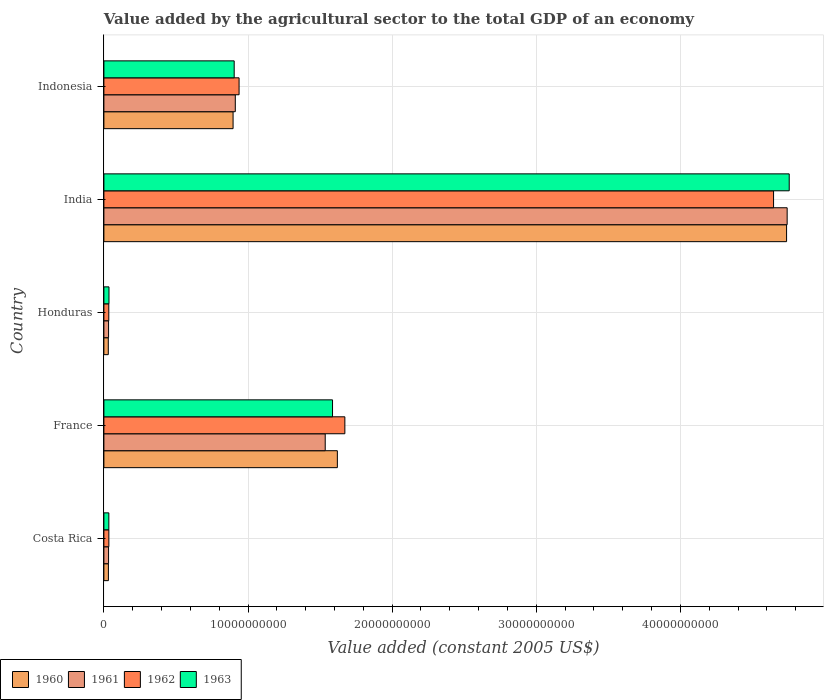How many different coloured bars are there?
Give a very brief answer. 4. Are the number of bars per tick equal to the number of legend labels?
Make the answer very short. Yes. How many bars are there on the 2nd tick from the top?
Ensure brevity in your answer.  4. How many bars are there on the 5th tick from the bottom?
Keep it short and to the point. 4. What is the value added by the agricultural sector in 1961 in Indonesia?
Provide a succinct answer. 9.12e+09. Across all countries, what is the maximum value added by the agricultural sector in 1962?
Provide a succinct answer. 4.65e+1. Across all countries, what is the minimum value added by the agricultural sector in 1962?
Provide a succinct answer. 3.41e+08. In which country was the value added by the agricultural sector in 1960 minimum?
Offer a terse response. Honduras. What is the total value added by the agricultural sector in 1961 in the graph?
Your answer should be very brief. 7.25e+1. What is the difference between the value added by the agricultural sector in 1960 in Honduras and that in Indonesia?
Provide a succinct answer. -8.66e+09. What is the difference between the value added by the agricultural sector in 1961 in India and the value added by the agricultural sector in 1960 in France?
Give a very brief answer. 3.12e+1. What is the average value added by the agricultural sector in 1961 per country?
Your answer should be compact. 1.45e+1. What is the difference between the value added by the agricultural sector in 1963 and value added by the agricultural sector in 1962 in Honduras?
Provide a short and direct response. 1.24e+07. In how many countries, is the value added by the agricultural sector in 1961 greater than 24000000000 US$?
Offer a very short reply. 1. What is the ratio of the value added by the agricultural sector in 1961 in France to that in Indonesia?
Keep it short and to the point. 1.68. Is the value added by the agricultural sector in 1963 in Costa Rica less than that in India?
Give a very brief answer. Yes. What is the difference between the highest and the second highest value added by the agricultural sector in 1963?
Give a very brief answer. 3.17e+1. What is the difference between the highest and the lowest value added by the agricultural sector in 1962?
Offer a terse response. 4.61e+1. In how many countries, is the value added by the agricultural sector in 1962 greater than the average value added by the agricultural sector in 1962 taken over all countries?
Offer a very short reply. 2. Is the sum of the value added by the agricultural sector in 1960 in Costa Rica and Indonesia greater than the maximum value added by the agricultural sector in 1961 across all countries?
Make the answer very short. No. Is it the case that in every country, the sum of the value added by the agricultural sector in 1961 and value added by the agricultural sector in 1962 is greater than the sum of value added by the agricultural sector in 1960 and value added by the agricultural sector in 1963?
Keep it short and to the point. No. What does the 1st bar from the top in India represents?
Provide a short and direct response. 1963. What does the 3rd bar from the bottom in Indonesia represents?
Your answer should be very brief. 1962. How many bars are there?
Ensure brevity in your answer.  20. Are all the bars in the graph horizontal?
Offer a very short reply. Yes. How many countries are there in the graph?
Your response must be concise. 5. What is the difference between two consecutive major ticks on the X-axis?
Offer a terse response. 1.00e+1. Does the graph contain any zero values?
Ensure brevity in your answer.  No. Does the graph contain grids?
Provide a short and direct response. Yes. How many legend labels are there?
Make the answer very short. 4. What is the title of the graph?
Keep it short and to the point. Value added by the agricultural sector to the total GDP of an economy. Does "1995" appear as one of the legend labels in the graph?
Make the answer very short. No. What is the label or title of the X-axis?
Offer a terse response. Value added (constant 2005 US$). What is the label or title of the Y-axis?
Offer a terse response. Country. What is the Value added (constant 2005 US$) of 1960 in Costa Rica?
Your answer should be very brief. 3.13e+08. What is the Value added (constant 2005 US$) in 1961 in Costa Rica?
Ensure brevity in your answer.  3.24e+08. What is the Value added (constant 2005 US$) in 1962 in Costa Rica?
Provide a short and direct response. 3.44e+08. What is the Value added (constant 2005 US$) in 1963 in Costa Rica?
Offer a terse response. 3.43e+08. What is the Value added (constant 2005 US$) in 1960 in France?
Your response must be concise. 1.62e+1. What is the Value added (constant 2005 US$) of 1961 in France?
Offer a very short reply. 1.54e+1. What is the Value added (constant 2005 US$) of 1962 in France?
Offer a very short reply. 1.67e+1. What is the Value added (constant 2005 US$) of 1963 in France?
Your response must be concise. 1.59e+1. What is the Value added (constant 2005 US$) in 1960 in Honduras?
Keep it short and to the point. 3.05e+08. What is the Value added (constant 2005 US$) in 1961 in Honduras?
Offer a very short reply. 3.25e+08. What is the Value added (constant 2005 US$) in 1962 in Honduras?
Your answer should be compact. 3.41e+08. What is the Value added (constant 2005 US$) of 1963 in Honduras?
Provide a short and direct response. 3.53e+08. What is the Value added (constant 2005 US$) of 1960 in India?
Make the answer very short. 4.74e+1. What is the Value added (constant 2005 US$) of 1961 in India?
Provide a short and direct response. 4.74e+1. What is the Value added (constant 2005 US$) of 1962 in India?
Provide a short and direct response. 4.65e+1. What is the Value added (constant 2005 US$) of 1963 in India?
Provide a succinct answer. 4.76e+1. What is the Value added (constant 2005 US$) of 1960 in Indonesia?
Your answer should be compact. 8.96e+09. What is the Value added (constant 2005 US$) of 1961 in Indonesia?
Provide a succinct answer. 9.12e+09. What is the Value added (constant 2005 US$) in 1962 in Indonesia?
Ensure brevity in your answer.  9.38e+09. What is the Value added (constant 2005 US$) in 1963 in Indonesia?
Your answer should be very brief. 9.04e+09. Across all countries, what is the maximum Value added (constant 2005 US$) in 1960?
Give a very brief answer. 4.74e+1. Across all countries, what is the maximum Value added (constant 2005 US$) of 1961?
Offer a terse response. 4.74e+1. Across all countries, what is the maximum Value added (constant 2005 US$) in 1962?
Offer a very short reply. 4.65e+1. Across all countries, what is the maximum Value added (constant 2005 US$) of 1963?
Give a very brief answer. 4.76e+1. Across all countries, what is the minimum Value added (constant 2005 US$) of 1960?
Give a very brief answer. 3.05e+08. Across all countries, what is the minimum Value added (constant 2005 US$) in 1961?
Provide a short and direct response. 3.24e+08. Across all countries, what is the minimum Value added (constant 2005 US$) of 1962?
Your answer should be very brief. 3.41e+08. Across all countries, what is the minimum Value added (constant 2005 US$) of 1963?
Provide a short and direct response. 3.43e+08. What is the total Value added (constant 2005 US$) of 1960 in the graph?
Provide a succinct answer. 7.31e+1. What is the total Value added (constant 2005 US$) of 1961 in the graph?
Give a very brief answer. 7.25e+1. What is the total Value added (constant 2005 US$) in 1962 in the graph?
Provide a succinct answer. 7.32e+1. What is the total Value added (constant 2005 US$) of 1963 in the graph?
Provide a short and direct response. 7.32e+1. What is the difference between the Value added (constant 2005 US$) of 1960 in Costa Rica and that in France?
Your response must be concise. -1.59e+1. What is the difference between the Value added (constant 2005 US$) in 1961 in Costa Rica and that in France?
Provide a succinct answer. -1.50e+1. What is the difference between the Value added (constant 2005 US$) of 1962 in Costa Rica and that in France?
Your response must be concise. -1.64e+1. What is the difference between the Value added (constant 2005 US$) in 1963 in Costa Rica and that in France?
Provide a short and direct response. -1.55e+1. What is the difference between the Value added (constant 2005 US$) in 1960 in Costa Rica and that in Honduras?
Provide a short and direct response. 7.61e+06. What is the difference between the Value added (constant 2005 US$) of 1961 in Costa Rica and that in Honduras?
Ensure brevity in your answer.  -8.14e+05. What is the difference between the Value added (constant 2005 US$) of 1962 in Costa Rica and that in Honduras?
Make the answer very short. 3.61e+06. What is the difference between the Value added (constant 2005 US$) of 1963 in Costa Rica and that in Honduras?
Your answer should be compact. -9.78e+06. What is the difference between the Value added (constant 2005 US$) of 1960 in Costa Rica and that in India?
Provide a short and direct response. -4.71e+1. What is the difference between the Value added (constant 2005 US$) of 1961 in Costa Rica and that in India?
Ensure brevity in your answer.  -4.71e+1. What is the difference between the Value added (constant 2005 US$) of 1962 in Costa Rica and that in India?
Ensure brevity in your answer.  -4.61e+1. What is the difference between the Value added (constant 2005 US$) of 1963 in Costa Rica and that in India?
Your response must be concise. -4.72e+1. What is the difference between the Value added (constant 2005 US$) in 1960 in Costa Rica and that in Indonesia?
Ensure brevity in your answer.  -8.65e+09. What is the difference between the Value added (constant 2005 US$) in 1961 in Costa Rica and that in Indonesia?
Provide a short and direct response. -8.79e+09. What is the difference between the Value added (constant 2005 US$) of 1962 in Costa Rica and that in Indonesia?
Keep it short and to the point. -9.03e+09. What is the difference between the Value added (constant 2005 US$) in 1963 in Costa Rica and that in Indonesia?
Keep it short and to the point. -8.70e+09. What is the difference between the Value added (constant 2005 US$) of 1960 in France and that in Honduras?
Offer a very short reply. 1.59e+1. What is the difference between the Value added (constant 2005 US$) of 1961 in France and that in Honduras?
Keep it short and to the point. 1.50e+1. What is the difference between the Value added (constant 2005 US$) of 1962 in France and that in Honduras?
Provide a succinct answer. 1.64e+1. What is the difference between the Value added (constant 2005 US$) in 1963 in France and that in Honduras?
Make the answer very short. 1.55e+1. What is the difference between the Value added (constant 2005 US$) of 1960 in France and that in India?
Your response must be concise. -3.12e+1. What is the difference between the Value added (constant 2005 US$) of 1961 in France and that in India?
Make the answer very short. -3.21e+1. What is the difference between the Value added (constant 2005 US$) in 1962 in France and that in India?
Offer a terse response. -2.97e+1. What is the difference between the Value added (constant 2005 US$) in 1963 in France and that in India?
Provide a succinct answer. -3.17e+1. What is the difference between the Value added (constant 2005 US$) of 1960 in France and that in Indonesia?
Make the answer very short. 7.24e+09. What is the difference between the Value added (constant 2005 US$) of 1961 in France and that in Indonesia?
Your answer should be compact. 6.24e+09. What is the difference between the Value added (constant 2005 US$) of 1962 in France and that in Indonesia?
Offer a very short reply. 7.34e+09. What is the difference between the Value added (constant 2005 US$) of 1963 in France and that in Indonesia?
Provide a succinct answer. 6.82e+09. What is the difference between the Value added (constant 2005 US$) of 1960 in Honduras and that in India?
Your answer should be compact. -4.71e+1. What is the difference between the Value added (constant 2005 US$) in 1961 in Honduras and that in India?
Your answer should be compact. -4.71e+1. What is the difference between the Value added (constant 2005 US$) of 1962 in Honduras and that in India?
Keep it short and to the point. -4.61e+1. What is the difference between the Value added (constant 2005 US$) of 1963 in Honduras and that in India?
Provide a short and direct response. -4.72e+1. What is the difference between the Value added (constant 2005 US$) in 1960 in Honduras and that in Indonesia?
Offer a very short reply. -8.66e+09. What is the difference between the Value added (constant 2005 US$) in 1961 in Honduras and that in Indonesia?
Your answer should be very brief. -8.79e+09. What is the difference between the Value added (constant 2005 US$) in 1962 in Honduras and that in Indonesia?
Offer a very short reply. -9.04e+09. What is the difference between the Value added (constant 2005 US$) of 1963 in Honduras and that in Indonesia?
Provide a short and direct response. -8.69e+09. What is the difference between the Value added (constant 2005 US$) in 1960 in India and that in Indonesia?
Make the answer very short. 3.84e+1. What is the difference between the Value added (constant 2005 US$) in 1961 in India and that in Indonesia?
Keep it short and to the point. 3.83e+1. What is the difference between the Value added (constant 2005 US$) in 1962 in India and that in Indonesia?
Give a very brief answer. 3.71e+1. What is the difference between the Value added (constant 2005 US$) of 1963 in India and that in Indonesia?
Keep it short and to the point. 3.85e+1. What is the difference between the Value added (constant 2005 US$) of 1960 in Costa Rica and the Value added (constant 2005 US$) of 1961 in France?
Your answer should be very brief. -1.50e+1. What is the difference between the Value added (constant 2005 US$) in 1960 in Costa Rica and the Value added (constant 2005 US$) in 1962 in France?
Offer a very short reply. -1.64e+1. What is the difference between the Value added (constant 2005 US$) in 1960 in Costa Rica and the Value added (constant 2005 US$) in 1963 in France?
Provide a succinct answer. -1.56e+1. What is the difference between the Value added (constant 2005 US$) of 1961 in Costa Rica and the Value added (constant 2005 US$) of 1962 in France?
Keep it short and to the point. -1.64e+1. What is the difference between the Value added (constant 2005 US$) of 1961 in Costa Rica and the Value added (constant 2005 US$) of 1963 in France?
Offer a very short reply. -1.55e+1. What is the difference between the Value added (constant 2005 US$) in 1962 in Costa Rica and the Value added (constant 2005 US$) in 1963 in France?
Your answer should be very brief. -1.55e+1. What is the difference between the Value added (constant 2005 US$) of 1960 in Costa Rica and the Value added (constant 2005 US$) of 1961 in Honduras?
Your answer should be very brief. -1.23e+07. What is the difference between the Value added (constant 2005 US$) in 1960 in Costa Rica and the Value added (constant 2005 US$) in 1962 in Honduras?
Ensure brevity in your answer.  -2.78e+07. What is the difference between the Value added (constant 2005 US$) in 1960 in Costa Rica and the Value added (constant 2005 US$) in 1963 in Honduras?
Provide a succinct answer. -4.02e+07. What is the difference between the Value added (constant 2005 US$) of 1961 in Costa Rica and the Value added (constant 2005 US$) of 1962 in Honduras?
Offer a terse response. -1.63e+07. What is the difference between the Value added (constant 2005 US$) of 1961 in Costa Rica and the Value added (constant 2005 US$) of 1963 in Honduras?
Offer a very short reply. -2.87e+07. What is the difference between the Value added (constant 2005 US$) of 1962 in Costa Rica and the Value added (constant 2005 US$) of 1963 in Honduras?
Provide a short and direct response. -8.78e+06. What is the difference between the Value added (constant 2005 US$) of 1960 in Costa Rica and the Value added (constant 2005 US$) of 1961 in India?
Provide a succinct answer. -4.71e+1. What is the difference between the Value added (constant 2005 US$) in 1960 in Costa Rica and the Value added (constant 2005 US$) in 1962 in India?
Your answer should be compact. -4.62e+1. What is the difference between the Value added (constant 2005 US$) in 1960 in Costa Rica and the Value added (constant 2005 US$) in 1963 in India?
Make the answer very short. -4.72e+1. What is the difference between the Value added (constant 2005 US$) of 1961 in Costa Rica and the Value added (constant 2005 US$) of 1962 in India?
Provide a succinct answer. -4.61e+1. What is the difference between the Value added (constant 2005 US$) of 1961 in Costa Rica and the Value added (constant 2005 US$) of 1963 in India?
Keep it short and to the point. -4.72e+1. What is the difference between the Value added (constant 2005 US$) of 1962 in Costa Rica and the Value added (constant 2005 US$) of 1963 in India?
Your answer should be very brief. -4.72e+1. What is the difference between the Value added (constant 2005 US$) of 1960 in Costa Rica and the Value added (constant 2005 US$) of 1961 in Indonesia?
Your answer should be compact. -8.80e+09. What is the difference between the Value added (constant 2005 US$) in 1960 in Costa Rica and the Value added (constant 2005 US$) in 1962 in Indonesia?
Ensure brevity in your answer.  -9.07e+09. What is the difference between the Value added (constant 2005 US$) of 1960 in Costa Rica and the Value added (constant 2005 US$) of 1963 in Indonesia?
Give a very brief answer. -8.73e+09. What is the difference between the Value added (constant 2005 US$) in 1961 in Costa Rica and the Value added (constant 2005 US$) in 1962 in Indonesia?
Keep it short and to the point. -9.05e+09. What is the difference between the Value added (constant 2005 US$) in 1961 in Costa Rica and the Value added (constant 2005 US$) in 1963 in Indonesia?
Your answer should be compact. -8.72e+09. What is the difference between the Value added (constant 2005 US$) in 1962 in Costa Rica and the Value added (constant 2005 US$) in 1963 in Indonesia?
Offer a very short reply. -8.70e+09. What is the difference between the Value added (constant 2005 US$) in 1960 in France and the Value added (constant 2005 US$) in 1961 in Honduras?
Offer a terse response. 1.59e+1. What is the difference between the Value added (constant 2005 US$) of 1960 in France and the Value added (constant 2005 US$) of 1962 in Honduras?
Keep it short and to the point. 1.59e+1. What is the difference between the Value added (constant 2005 US$) in 1960 in France and the Value added (constant 2005 US$) in 1963 in Honduras?
Ensure brevity in your answer.  1.58e+1. What is the difference between the Value added (constant 2005 US$) in 1961 in France and the Value added (constant 2005 US$) in 1962 in Honduras?
Ensure brevity in your answer.  1.50e+1. What is the difference between the Value added (constant 2005 US$) of 1961 in France and the Value added (constant 2005 US$) of 1963 in Honduras?
Your response must be concise. 1.50e+1. What is the difference between the Value added (constant 2005 US$) of 1962 in France and the Value added (constant 2005 US$) of 1963 in Honduras?
Your answer should be very brief. 1.64e+1. What is the difference between the Value added (constant 2005 US$) in 1960 in France and the Value added (constant 2005 US$) in 1961 in India?
Keep it short and to the point. -3.12e+1. What is the difference between the Value added (constant 2005 US$) in 1960 in France and the Value added (constant 2005 US$) in 1962 in India?
Provide a short and direct response. -3.03e+1. What is the difference between the Value added (constant 2005 US$) of 1960 in France and the Value added (constant 2005 US$) of 1963 in India?
Make the answer very short. -3.14e+1. What is the difference between the Value added (constant 2005 US$) in 1961 in France and the Value added (constant 2005 US$) in 1962 in India?
Ensure brevity in your answer.  -3.11e+1. What is the difference between the Value added (constant 2005 US$) of 1961 in France and the Value added (constant 2005 US$) of 1963 in India?
Give a very brief answer. -3.22e+1. What is the difference between the Value added (constant 2005 US$) in 1962 in France and the Value added (constant 2005 US$) in 1963 in India?
Your response must be concise. -3.08e+1. What is the difference between the Value added (constant 2005 US$) of 1960 in France and the Value added (constant 2005 US$) of 1961 in Indonesia?
Your response must be concise. 7.08e+09. What is the difference between the Value added (constant 2005 US$) of 1960 in France and the Value added (constant 2005 US$) of 1962 in Indonesia?
Give a very brief answer. 6.82e+09. What is the difference between the Value added (constant 2005 US$) in 1960 in France and the Value added (constant 2005 US$) in 1963 in Indonesia?
Offer a very short reply. 7.16e+09. What is the difference between the Value added (constant 2005 US$) in 1961 in France and the Value added (constant 2005 US$) in 1962 in Indonesia?
Your answer should be compact. 5.98e+09. What is the difference between the Value added (constant 2005 US$) in 1961 in France and the Value added (constant 2005 US$) in 1963 in Indonesia?
Offer a very short reply. 6.32e+09. What is the difference between the Value added (constant 2005 US$) in 1962 in France and the Value added (constant 2005 US$) in 1963 in Indonesia?
Offer a very short reply. 7.68e+09. What is the difference between the Value added (constant 2005 US$) in 1960 in Honduras and the Value added (constant 2005 US$) in 1961 in India?
Offer a very short reply. -4.71e+1. What is the difference between the Value added (constant 2005 US$) in 1960 in Honduras and the Value added (constant 2005 US$) in 1962 in India?
Offer a terse response. -4.62e+1. What is the difference between the Value added (constant 2005 US$) of 1960 in Honduras and the Value added (constant 2005 US$) of 1963 in India?
Your response must be concise. -4.72e+1. What is the difference between the Value added (constant 2005 US$) in 1961 in Honduras and the Value added (constant 2005 US$) in 1962 in India?
Make the answer very short. -4.61e+1. What is the difference between the Value added (constant 2005 US$) in 1961 in Honduras and the Value added (constant 2005 US$) in 1963 in India?
Give a very brief answer. -4.72e+1. What is the difference between the Value added (constant 2005 US$) in 1962 in Honduras and the Value added (constant 2005 US$) in 1963 in India?
Provide a succinct answer. -4.72e+1. What is the difference between the Value added (constant 2005 US$) of 1960 in Honduras and the Value added (constant 2005 US$) of 1961 in Indonesia?
Your answer should be very brief. -8.81e+09. What is the difference between the Value added (constant 2005 US$) in 1960 in Honduras and the Value added (constant 2005 US$) in 1962 in Indonesia?
Give a very brief answer. -9.07e+09. What is the difference between the Value added (constant 2005 US$) in 1960 in Honduras and the Value added (constant 2005 US$) in 1963 in Indonesia?
Your response must be concise. -8.73e+09. What is the difference between the Value added (constant 2005 US$) of 1961 in Honduras and the Value added (constant 2005 US$) of 1962 in Indonesia?
Provide a succinct answer. -9.05e+09. What is the difference between the Value added (constant 2005 US$) of 1961 in Honduras and the Value added (constant 2005 US$) of 1963 in Indonesia?
Provide a short and direct response. -8.72e+09. What is the difference between the Value added (constant 2005 US$) of 1962 in Honduras and the Value added (constant 2005 US$) of 1963 in Indonesia?
Provide a succinct answer. -8.70e+09. What is the difference between the Value added (constant 2005 US$) of 1960 in India and the Value added (constant 2005 US$) of 1961 in Indonesia?
Provide a short and direct response. 3.83e+1. What is the difference between the Value added (constant 2005 US$) of 1960 in India and the Value added (constant 2005 US$) of 1962 in Indonesia?
Keep it short and to the point. 3.80e+1. What is the difference between the Value added (constant 2005 US$) of 1960 in India and the Value added (constant 2005 US$) of 1963 in Indonesia?
Your answer should be very brief. 3.83e+1. What is the difference between the Value added (constant 2005 US$) of 1961 in India and the Value added (constant 2005 US$) of 1962 in Indonesia?
Keep it short and to the point. 3.80e+1. What is the difference between the Value added (constant 2005 US$) in 1961 in India and the Value added (constant 2005 US$) in 1963 in Indonesia?
Keep it short and to the point. 3.84e+1. What is the difference between the Value added (constant 2005 US$) in 1962 in India and the Value added (constant 2005 US$) in 1963 in Indonesia?
Offer a terse response. 3.74e+1. What is the average Value added (constant 2005 US$) in 1960 per country?
Give a very brief answer. 1.46e+1. What is the average Value added (constant 2005 US$) of 1961 per country?
Provide a succinct answer. 1.45e+1. What is the average Value added (constant 2005 US$) in 1962 per country?
Offer a very short reply. 1.46e+1. What is the average Value added (constant 2005 US$) in 1963 per country?
Your answer should be compact. 1.46e+1. What is the difference between the Value added (constant 2005 US$) of 1960 and Value added (constant 2005 US$) of 1961 in Costa Rica?
Offer a terse response. -1.15e+07. What is the difference between the Value added (constant 2005 US$) in 1960 and Value added (constant 2005 US$) in 1962 in Costa Rica?
Your answer should be compact. -3.14e+07. What is the difference between the Value added (constant 2005 US$) of 1960 and Value added (constant 2005 US$) of 1963 in Costa Rica?
Offer a terse response. -3.04e+07. What is the difference between the Value added (constant 2005 US$) of 1961 and Value added (constant 2005 US$) of 1962 in Costa Rica?
Ensure brevity in your answer.  -1.99e+07. What is the difference between the Value added (constant 2005 US$) in 1961 and Value added (constant 2005 US$) in 1963 in Costa Rica?
Provide a succinct answer. -1.89e+07. What is the difference between the Value added (constant 2005 US$) in 1962 and Value added (constant 2005 US$) in 1963 in Costa Rica?
Give a very brief answer. 1.00e+06. What is the difference between the Value added (constant 2005 US$) of 1960 and Value added (constant 2005 US$) of 1961 in France?
Your answer should be compact. 8.42e+08. What is the difference between the Value added (constant 2005 US$) in 1960 and Value added (constant 2005 US$) in 1962 in France?
Ensure brevity in your answer.  -5.20e+08. What is the difference between the Value added (constant 2005 US$) of 1960 and Value added (constant 2005 US$) of 1963 in France?
Provide a succinct answer. 3.35e+08. What is the difference between the Value added (constant 2005 US$) in 1961 and Value added (constant 2005 US$) in 1962 in France?
Provide a short and direct response. -1.36e+09. What is the difference between the Value added (constant 2005 US$) of 1961 and Value added (constant 2005 US$) of 1963 in France?
Give a very brief answer. -5.07e+08. What is the difference between the Value added (constant 2005 US$) of 1962 and Value added (constant 2005 US$) of 1963 in France?
Your response must be concise. 8.56e+08. What is the difference between the Value added (constant 2005 US$) in 1960 and Value added (constant 2005 US$) in 1961 in Honduras?
Keep it short and to the point. -1.99e+07. What is the difference between the Value added (constant 2005 US$) in 1960 and Value added (constant 2005 US$) in 1962 in Honduras?
Provide a short and direct response. -3.54e+07. What is the difference between the Value added (constant 2005 US$) in 1960 and Value added (constant 2005 US$) in 1963 in Honduras?
Offer a terse response. -4.78e+07. What is the difference between the Value added (constant 2005 US$) in 1961 and Value added (constant 2005 US$) in 1962 in Honduras?
Your answer should be very brief. -1.55e+07. What is the difference between the Value added (constant 2005 US$) of 1961 and Value added (constant 2005 US$) of 1963 in Honduras?
Provide a short and direct response. -2.79e+07. What is the difference between the Value added (constant 2005 US$) of 1962 and Value added (constant 2005 US$) of 1963 in Honduras?
Give a very brief answer. -1.24e+07. What is the difference between the Value added (constant 2005 US$) of 1960 and Value added (constant 2005 US$) of 1961 in India?
Make the answer very short. -3.99e+07. What is the difference between the Value added (constant 2005 US$) of 1960 and Value added (constant 2005 US$) of 1962 in India?
Your response must be concise. 9.03e+08. What is the difference between the Value added (constant 2005 US$) in 1960 and Value added (constant 2005 US$) in 1963 in India?
Give a very brief answer. -1.84e+08. What is the difference between the Value added (constant 2005 US$) in 1961 and Value added (constant 2005 US$) in 1962 in India?
Ensure brevity in your answer.  9.43e+08. What is the difference between the Value added (constant 2005 US$) of 1961 and Value added (constant 2005 US$) of 1963 in India?
Offer a very short reply. -1.44e+08. What is the difference between the Value added (constant 2005 US$) of 1962 and Value added (constant 2005 US$) of 1963 in India?
Offer a very short reply. -1.09e+09. What is the difference between the Value added (constant 2005 US$) in 1960 and Value added (constant 2005 US$) in 1961 in Indonesia?
Give a very brief answer. -1.54e+08. What is the difference between the Value added (constant 2005 US$) in 1960 and Value added (constant 2005 US$) in 1962 in Indonesia?
Your response must be concise. -4.16e+08. What is the difference between the Value added (constant 2005 US$) in 1960 and Value added (constant 2005 US$) in 1963 in Indonesia?
Your answer should be very brief. -7.71e+07. What is the difference between the Value added (constant 2005 US$) in 1961 and Value added (constant 2005 US$) in 1962 in Indonesia?
Keep it short and to the point. -2.62e+08. What is the difference between the Value added (constant 2005 US$) in 1961 and Value added (constant 2005 US$) in 1963 in Indonesia?
Offer a very short reply. 7.71e+07. What is the difference between the Value added (constant 2005 US$) in 1962 and Value added (constant 2005 US$) in 1963 in Indonesia?
Offer a very short reply. 3.39e+08. What is the ratio of the Value added (constant 2005 US$) of 1960 in Costa Rica to that in France?
Keep it short and to the point. 0.02. What is the ratio of the Value added (constant 2005 US$) in 1961 in Costa Rica to that in France?
Give a very brief answer. 0.02. What is the ratio of the Value added (constant 2005 US$) in 1962 in Costa Rica to that in France?
Provide a succinct answer. 0.02. What is the ratio of the Value added (constant 2005 US$) in 1963 in Costa Rica to that in France?
Offer a terse response. 0.02. What is the ratio of the Value added (constant 2005 US$) of 1960 in Costa Rica to that in Honduras?
Give a very brief answer. 1.02. What is the ratio of the Value added (constant 2005 US$) in 1962 in Costa Rica to that in Honduras?
Provide a short and direct response. 1.01. What is the ratio of the Value added (constant 2005 US$) of 1963 in Costa Rica to that in Honduras?
Your answer should be very brief. 0.97. What is the ratio of the Value added (constant 2005 US$) in 1960 in Costa Rica to that in India?
Make the answer very short. 0.01. What is the ratio of the Value added (constant 2005 US$) in 1961 in Costa Rica to that in India?
Provide a short and direct response. 0.01. What is the ratio of the Value added (constant 2005 US$) of 1962 in Costa Rica to that in India?
Offer a terse response. 0.01. What is the ratio of the Value added (constant 2005 US$) in 1963 in Costa Rica to that in India?
Offer a terse response. 0.01. What is the ratio of the Value added (constant 2005 US$) of 1960 in Costa Rica to that in Indonesia?
Your response must be concise. 0.03. What is the ratio of the Value added (constant 2005 US$) in 1961 in Costa Rica to that in Indonesia?
Offer a very short reply. 0.04. What is the ratio of the Value added (constant 2005 US$) of 1962 in Costa Rica to that in Indonesia?
Make the answer very short. 0.04. What is the ratio of the Value added (constant 2005 US$) in 1963 in Costa Rica to that in Indonesia?
Your answer should be very brief. 0.04. What is the ratio of the Value added (constant 2005 US$) in 1960 in France to that in Honduras?
Your response must be concise. 53.05. What is the ratio of the Value added (constant 2005 US$) in 1961 in France to that in Honduras?
Keep it short and to the point. 47.21. What is the ratio of the Value added (constant 2005 US$) in 1962 in France to that in Honduras?
Your response must be concise. 49.07. What is the ratio of the Value added (constant 2005 US$) of 1963 in France to that in Honduras?
Ensure brevity in your answer.  44.92. What is the ratio of the Value added (constant 2005 US$) of 1960 in France to that in India?
Offer a terse response. 0.34. What is the ratio of the Value added (constant 2005 US$) in 1961 in France to that in India?
Give a very brief answer. 0.32. What is the ratio of the Value added (constant 2005 US$) in 1962 in France to that in India?
Your response must be concise. 0.36. What is the ratio of the Value added (constant 2005 US$) in 1963 in France to that in India?
Make the answer very short. 0.33. What is the ratio of the Value added (constant 2005 US$) of 1960 in France to that in Indonesia?
Offer a very short reply. 1.81. What is the ratio of the Value added (constant 2005 US$) of 1961 in France to that in Indonesia?
Your response must be concise. 1.68. What is the ratio of the Value added (constant 2005 US$) of 1962 in France to that in Indonesia?
Give a very brief answer. 1.78. What is the ratio of the Value added (constant 2005 US$) in 1963 in France to that in Indonesia?
Offer a terse response. 1.75. What is the ratio of the Value added (constant 2005 US$) of 1960 in Honduras to that in India?
Offer a terse response. 0.01. What is the ratio of the Value added (constant 2005 US$) in 1961 in Honduras to that in India?
Give a very brief answer. 0.01. What is the ratio of the Value added (constant 2005 US$) of 1962 in Honduras to that in India?
Ensure brevity in your answer.  0.01. What is the ratio of the Value added (constant 2005 US$) of 1963 in Honduras to that in India?
Keep it short and to the point. 0.01. What is the ratio of the Value added (constant 2005 US$) of 1960 in Honduras to that in Indonesia?
Offer a terse response. 0.03. What is the ratio of the Value added (constant 2005 US$) of 1961 in Honduras to that in Indonesia?
Your response must be concise. 0.04. What is the ratio of the Value added (constant 2005 US$) of 1962 in Honduras to that in Indonesia?
Ensure brevity in your answer.  0.04. What is the ratio of the Value added (constant 2005 US$) in 1963 in Honduras to that in Indonesia?
Give a very brief answer. 0.04. What is the ratio of the Value added (constant 2005 US$) of 1960 in India to that in Indonesia?
Provide a short and direct response. 5.28. What is the ratio of the Value added (constant 2005 US$) in 1961 in India to that in Indonesia?
Provide a short and direct response. 5.2. What is the ratio of the Value added (constant 2005 US$) in 1962 in India to that in Indonesia?
Your answer should be compact. 4.95. What is the ratio of the Value added (constant 2005 US$) in 1963 in India to that in Indonesia?
Offer a terse response. 5.26. What is the difference between the highest and the second highest Value added (constant 2005 US$) of 1960?
Your answer should be very brief. 3.12e+1. What is the difference between the highest and the second highest Value added (constant 2005 US$) in 1961?
Make the answer very short. 3.21e+1. What is the difference between the highest and the second highest Value added (constant 2005 US$) of 1962?
Offer a very short reply. 2.97e+1. What is the difference between the highest and the second highest Value added (constant 2005 US$) in 1963?
Provide a succinct answer. 3.17e+1. What is the difference between the highest and the lowest Value added (constant 2005 US$) in 1960?
Your answer should be compact. 4.71e+1. What is the difference between the highest and the lowest Value added (constant 2005 US$) of 1961?
Offer a very short reply. 4.71e+1. What is the difference between the highest and the lowest Value added (constant 2005 US$) of 1962?
Your answer should be very brief. 4.61e+1. What is the difference between the highest and the lowest Value added (constant 2005 US$) of 1963?
Make the answer very short. 4.72e+1. 